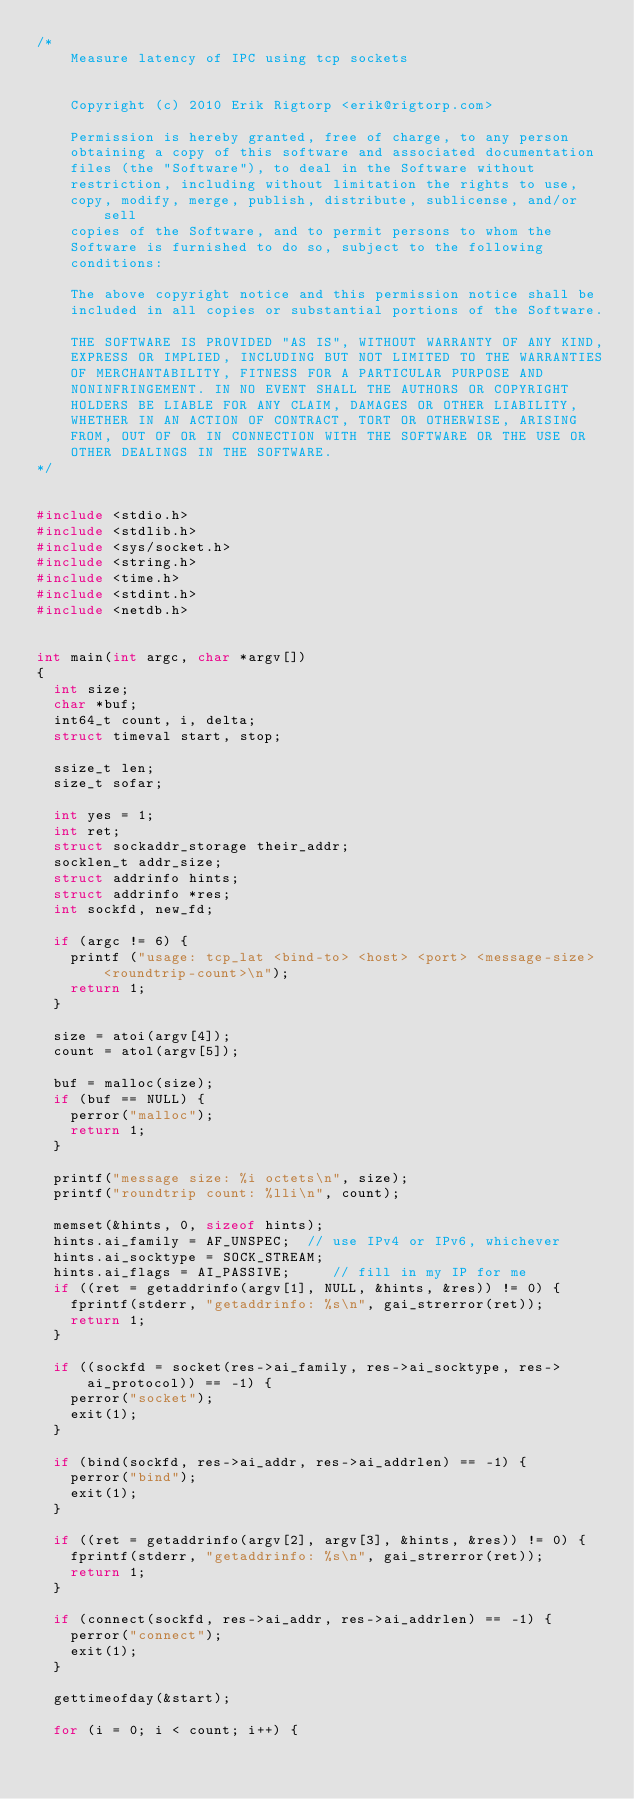<code> <loc_0><loc_0><loc_500><loc_500><_C_>/* 
    Measure latency of IPC using tcp sockets


    Copyright (c) 2010 Erik Rigtorp <erik@rigtorp.com>

    Permission is hereby granted, free of charge, to any person
    obtaining a copy of this software and associated documentation
    files (the "Software"), to deal in the Software without
    restriction, including without limitation the rights to use,
    copy, modify, merge, publish, distribute, sublicense, and/or sell
    copies of the Software, and to permit persons to whom the
    Software is furnished to do so, subject to the following
    conditions:

    The above copyright notice and this permission notice shall be
    included in all copies or substantial portions of the Software.

    THE SOFTWARE IS PROVIDED "AS IS", WITHOUT WARRANTY OF ANY KIND,
    EXPRESS OR IMPLIED, INCLUDING BUT NOT LIMITED TO THE WARRANTIES
    OF MERCHANTABILITY, FITNESS FOR A PARTICULAR PURPOSE AND
    NONINFRINGEMENT. IN NO EVENT SHALL THE AUTHORS OR COPYRIGHT
    HOLDERS BE LIABLE FOR ANY CLAIM, DAMAGES OR OTHER LIABILITY,
    WHETHER IN AN ACTION OF CONTRACT, TORT OR OTHERWISE, ARISING
    FROM, OUT OF OR IN CONNECTION WITH THE SOFTWARE OR THE USE OR
    OTHER DEALINGS IN THE SOFTWARE.
*/


#include <stdio.h>
#include <stdlib.h>
#include <sys/socket.h>
#include <string.h>
#include <time.h>
#include <stdint.h>
#include <netdb.h>


int main(int argc, char *argv[])
{
  int size;
  char *buf;
  int64_t count, i, delta;
  struct timeval start, stop;

  ssize_t len;
  size_t sofar;

  int yes = 1;
  int ret;
  struct sockaddr_storage their_addr;
  socklen_t addr_size;
  struct addrinfo hints;
  struct addrinfo *res;
  int sockfd, new_fd;

  if (argc != 6) {
    printf ("usage: tcp_lat <bind-to> <host> <port> <message-size> <roundtrip-count>\n");
    return 1;
  }

  size = atoi(argv[4]);
  count = atol(argv[5]);

  buf = malloc(size);
  if (buf == NULL) {
    perror("malloc");
    return 1;
  }

  printf("message size: %i octets\n", size);
  printf("roundtrip count: %lli\n", count);

  memset(&hints, 0, sizeof hints);
  hints.ai_family = AF_UNSPEC;  // use IPv4 or IPv6, whichever
  hints.ai_socktype = SOCK_STREAM;
  hints.ai_flags = AI_PASSIVE;     // fill in my IP for me
  if ((ret = getaddrinfo(argv[1], NULL, &hints, &res)) != 0) {
    fprintf(stderr, "getaddrinfo: %s\n", gai_strerror(ret));
    return 1;
  }
    
  if ((sockfd = socket(res->ai_family, res->ai_socktype, res->ai_protocol)) == -1) {
    perror("socket");
    exit(1);
  }

  if (bind(sockfd, res->ai_addr, res->ai_addrlen) == -1) {
    perror("bind");
    exit(1);
  }

  if ((ret = getaddrinfo(argv[2], argv[3], &hints, &res)) != 0) {
    fprintf(stderr, "getaddrinfo: %s\n", gai_strerror(ret));
    return 1;
  }
    
  if (connect(sockfd, res->ai_addr, res->ai_addrlen) == -1) {
    perror("connect");
    exit(1);
  }

  gettimeofday(&start);

  for (i = 0; i < count; i++) {
</code> 